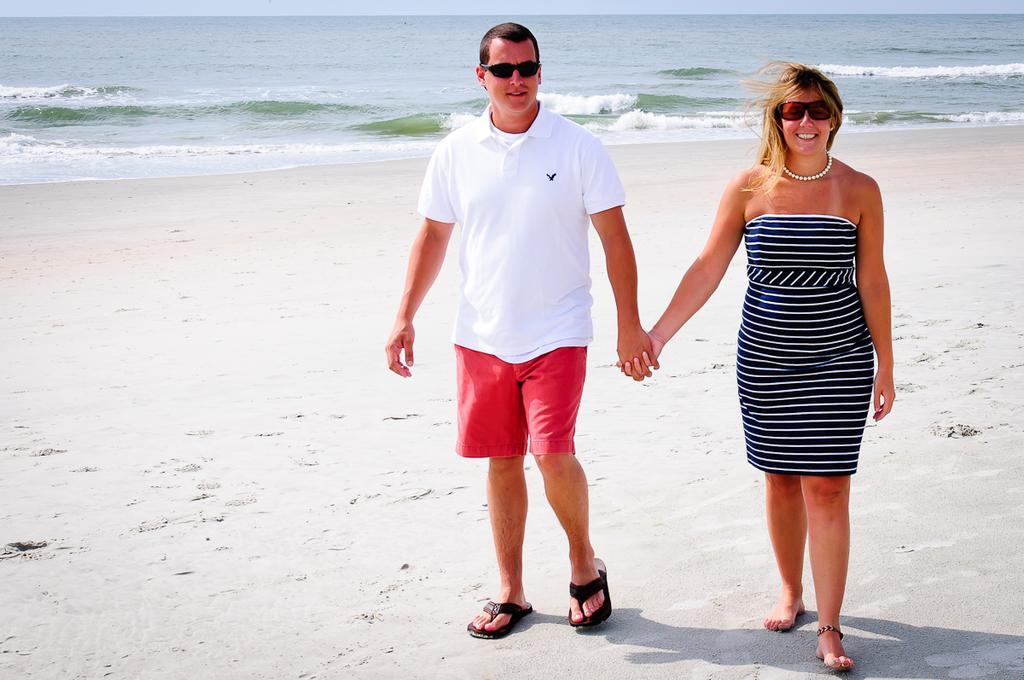Please provide a concise description of this image. In this picture we can see a man and a woman wore goggles and walking on sand and smiling and in the background we can see the water, sky. 